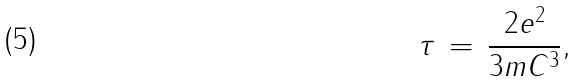<formula> <loc_0><loc_0><loc_500><loc_500>\, \tau \, = \, \frac { 2 e ^ { 2 } } { 3 m C ^ { 3 } } ,</formula> 